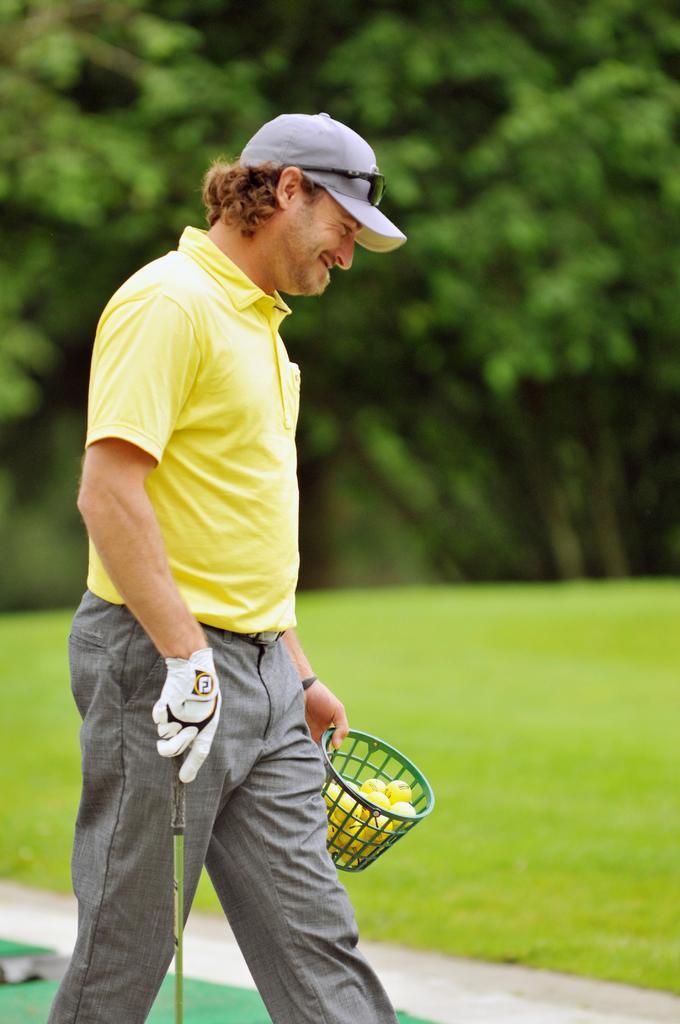Can you describe this image briefly? In this picture we can see a person holding balls basket, another hand we can see stick, side we can see grass and trees. 